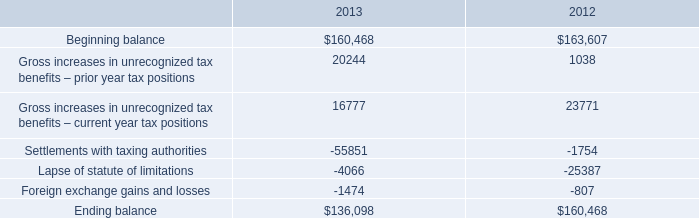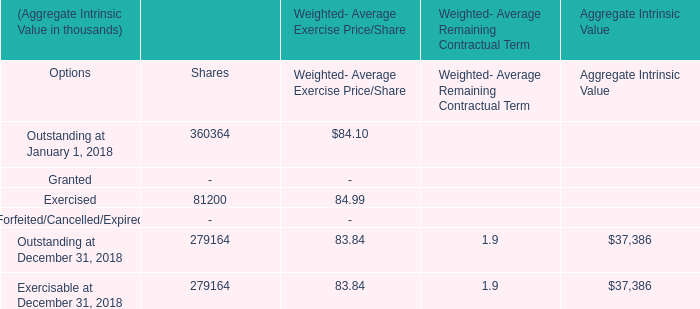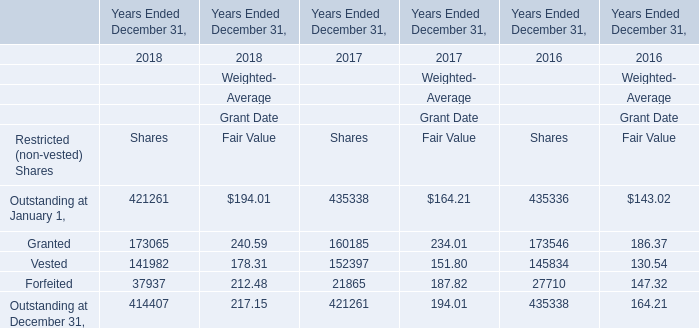What is the total amount of Forfeited of Years Ended December 31, 2016 Shares, and Settlements with taxing authorities of 2012 ? 
Computations: (27710.0 + 1754.0)
Answer: 29464.0. 